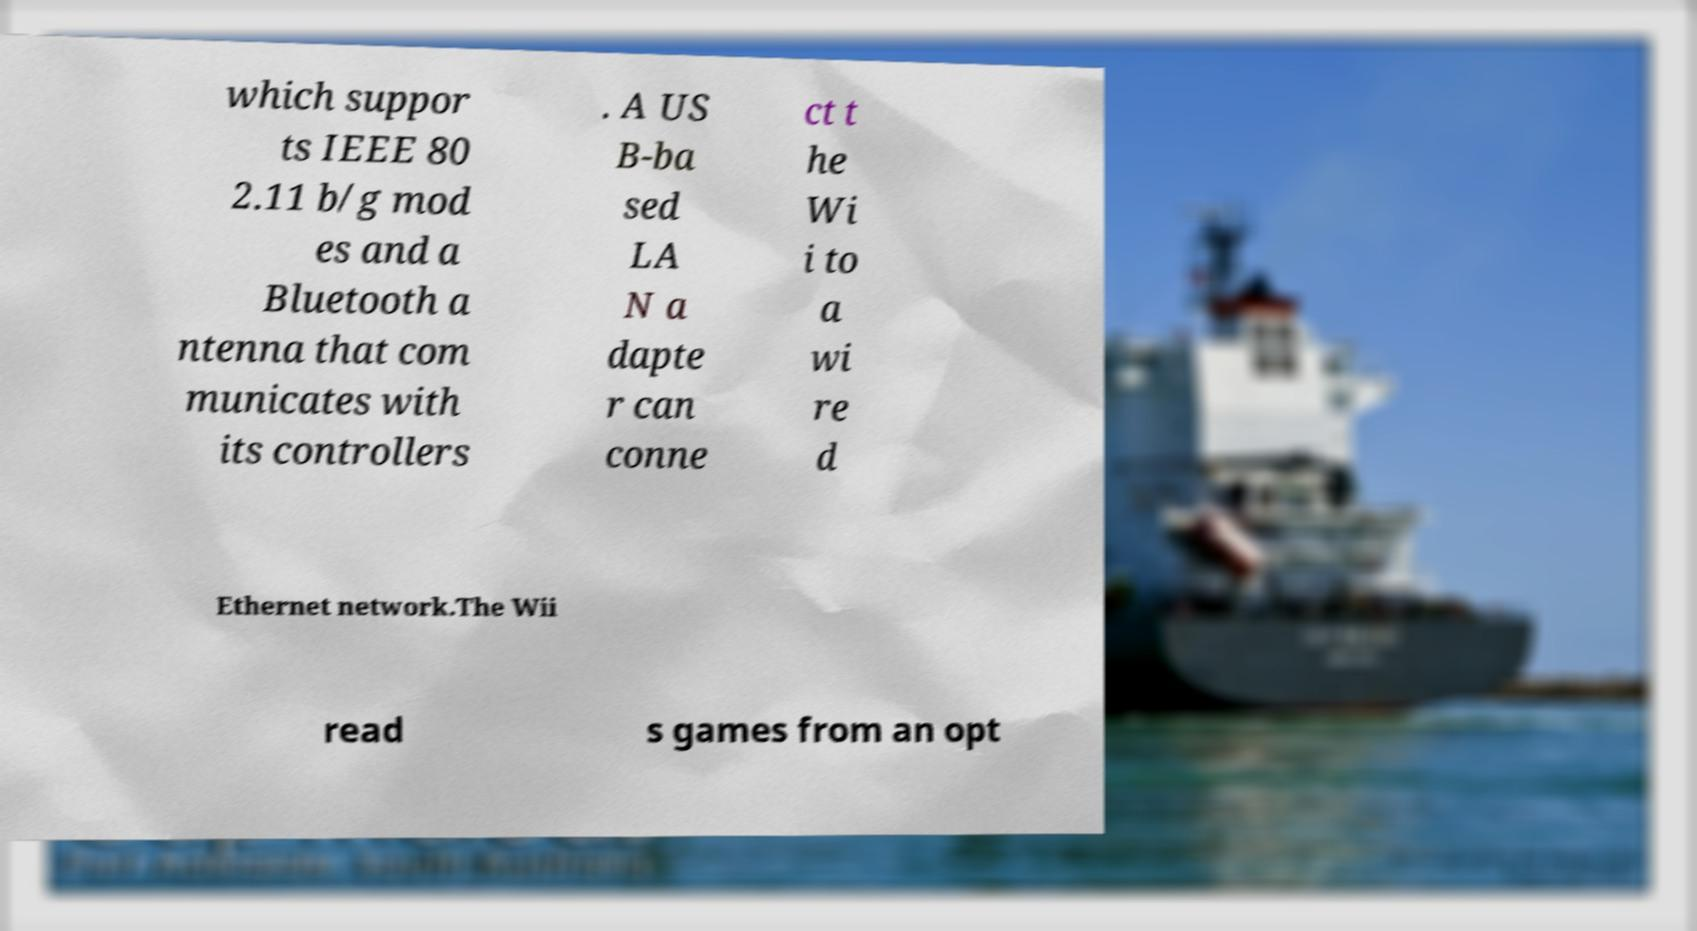What messages or text are displayed in this image? I need them in a readable, typed format. which suppor ts IEEE 80 2.11 b/g mod es and a Bluetooth a ntenna that com municates with its controllers . A US B-ba sed LA N a dapte r can conne ct t he Wi i to a wi re d Ethernet network.The Wii read s games from an opt 